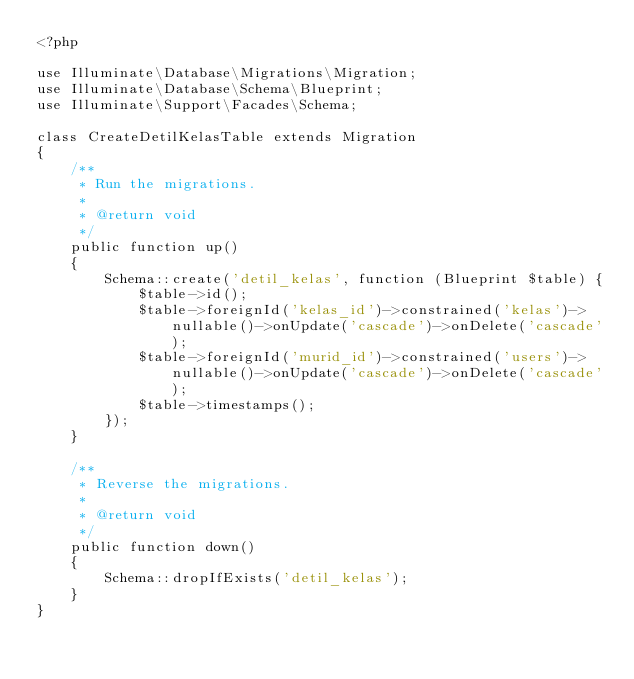Convert code to text. <code><loc_0><loc_0><loc_500><loc_500><_PHP_><?php

use Illuminate\Database\Migrations\Migration;
use Illuminate\Database\Schema\Blueprint;
use Illuminate\Support\Facades\Schema;

class CreateDetilKelasTable extends Migration
{
    /**
     * Run the migrations.
     *
     * @return void
     */
    public function up()
    {
        Schema::create('detil_kelas', function (Blueprint $table) {
            $table->id();
            $table->foreignId('kelas_id')->constrained('kelas')->nullable()->onUpdate('cascade')->onDelete('cascade');
            $table->foreignId('murid_id')->constrained('users')->nullable()->onUpdate('cascade')->onDelete('cascade');
            $table->timestamps();
        });
    }

    /**
     * Reverse the migrations.
     *
     * @return void
     */
    public function down()
    {
        Schema::dropIfExists('detil_kelas');
    }
}
</code> 